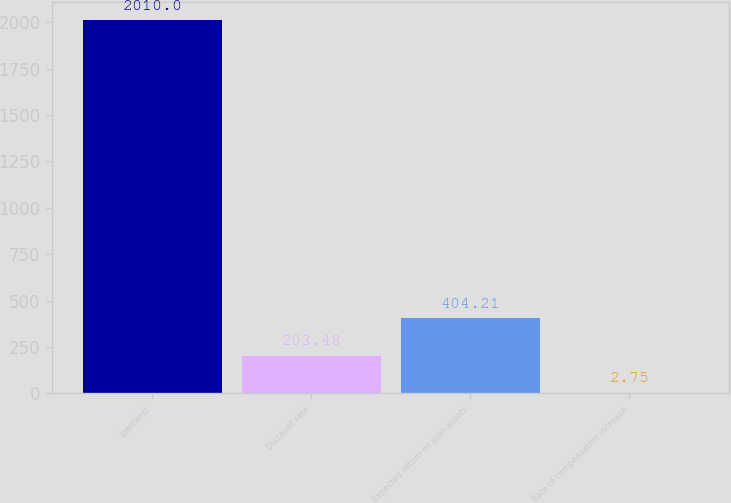Convert chart to OTSL. <chart><loc_0><loc_0><loc_500><loc_500><bar_chart><fcel>(percent)<fcel>Discount rate<fcel>Expected return on plan assets<fcel>Rate of compensation increase<nl><fcel>2010<fcel>203.48<fcel>404.21<fcel>2.75<nl></chart> 